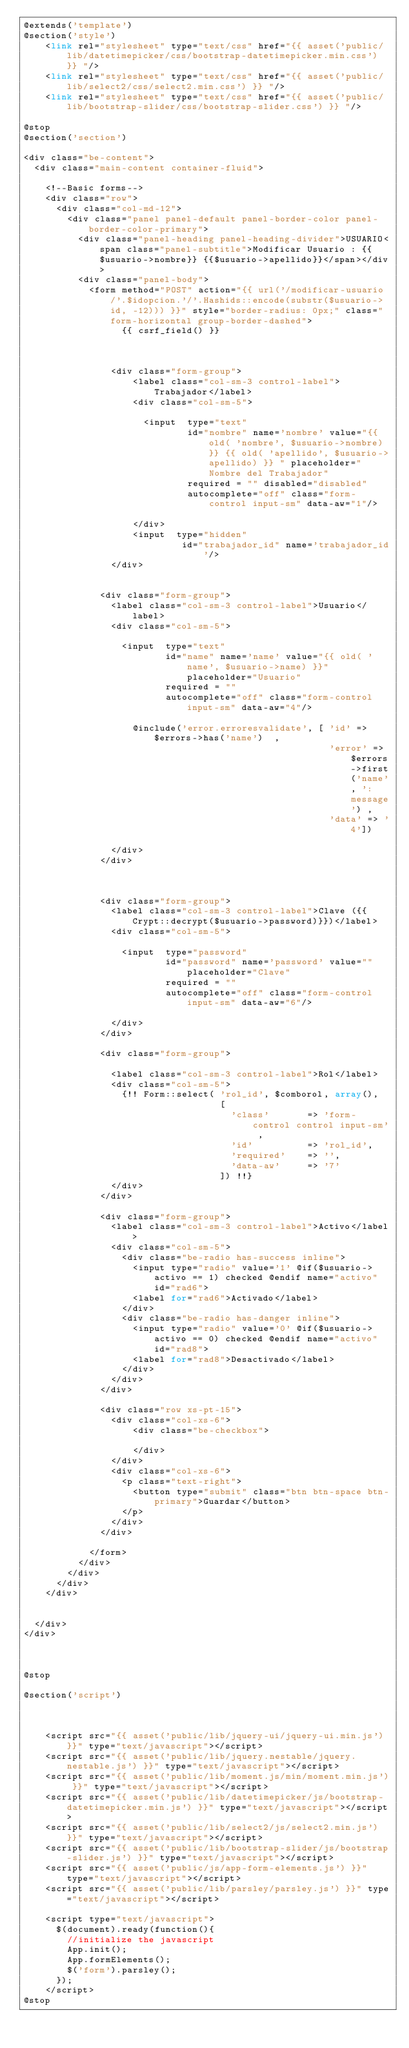Convert code to text. <code><loc_0><loc_0><loc_500><loc_500><_PHP_>@extends('template')
@section('style')
    <link rel="stylesheet" type="text/css" href="{{ asset('public/lib/datetimepicker/css/bootstrap-datetimepicker.min.css') }} "/>
    <link rel="stylesheet" type="text/css" href="{{ asset('public/lib/select2/css/select2.min.css') }} "/>
    <link rel="stylesheet" type="text/css" href="{{ asset('public/lib/bootstrap-slider/css/bootstrap-slider.css') }} "/>

@stop
@section('section')

<div class="be-content">
  <div class="main-content container-fluid">

    <!--Basic forms-->
    <div class="row">
      <div class="col-md-12">
        <div class="panel panel-default panel-border-color panel-border-color-primary">
          <div class="panel-heading panel-heading-divider">USUARIO<span class="panel-subtitle">Modificar Usuario : {{$usuario->nombre}} {{$usuario->apellido}}</span></div>
          <div class="panel-body">
            <form method="POST" action="{{ url('/modificar-usuario/'.$idopcion.'/'.Hashids::encode(substr($usuario->id, -12))) }}" style="border-radius: 0px;" class="form-horizontal group-border-dashed"> 
                  {{ csrf_field() }}


              
                <div class="form-group">
                    <label class="col-sm-3 control-label">Trabajador</label>
                    <div class="col-sm-5">

                      <input  type="text"
                              id="nombre" name='nombre' value="{{ old( 'nombre', $usuario->nombre) }} {{ old( 'apellido', $usuario->apellido) }} " placeholder="Nombre del Trabajador"
                              required = "" disabled="disabled"
                              autocomplete="off" class="form-control input-sm" data-aw="1"/>

                    </div>
                    <input  type="hidden"
                             id="trabajador_id" name='trabajador_id'/>
                </div>
            
            
              <div class="form-group">
                <label class="col-sm-3 control-label">Usuario</label>
                <div class="col-sm-5">

                  <input  type="text"
                          id="name" name='name' value="{{ old( 'name', $usuario->name) }}" placeholder="Usuario"
                          required = ""
                          autocomplete="off" class="form-control input-sm" data-aw="4"/>

                    @include('error.erroresvalidate', [ 'id' => $errors->has('name')  , 
                                                        'error' => $errors->first('name', ':message') , 
                                                        'data' => '4'])

                </div>
              </div>

  

              <div class="form-group">
                <label class="col-sm-3 control-label">Clave ({{Crypt::decrypt($usuario->password)}})</label>
                <div class="col-sm-5">

                  <input  type="password"
                          id="password" name='password' value="" placeholder="Clave"
                          required = ""
                          autocomplete="off" class="form-control input-sm" data-aw="6"/>

                </div>
              </div>

              <div class="form-group">

                <label class="col-sm-3 control-label">Rol</label>
                <div class="col-sm-5">
                  {!! Form::select( 'rol_id', $comborol, array(),
                                    [
                                      'class'       => 'form-control control input-sm' ,
                                      'id'          => 'rol_id',
                                      'required'    => '',
                                      'data-aw'     => '7'
                                    ]) !!}
                </div>
              </div>

              <div class="form-group">
                <label class="col-sm-3 control-label">Activo</label>
                <div class="col-sm-5">
                  <div class="be-radio has-success inline">
                    <input type="radio" value='1' @if($usuario->activo == 1) checked @endif name="activo" id="rad6">
                    <label for="rad6">Activado</label>
                  </div>
                  <div class="be-radio has-danger inline">
                    <input type="radio" value='0' @if($usuario->activo == 0) checked @endif name="activo" id="rad8">
                    <label for="rad8">Desactivado</label>
                  </div>
                </div>
              </div>              

              <div class="row xs-pt-15">
                <div class="col-xs-6">
                    <div class="be-checkbox">

                    </div>
                </div>
                <div class="col-xs-6">
                  <p class="text-right">
                    <button type="submit" class="btn btn-space btn-primary">Guardar</button>
                  </p>
                </div>
              </div>

            </form>
          </div>
        </div>
      </div>
    </div>


  </div>
</div>  



@stop

@section('script')



	  <script src="{{ asset('public/lib/jquery-ui/jquery-ui.min.js') }}" type="text/javascript"></script>
    <script src="{{ asset('public/lib/jquery.nestable/jquery.nestable.js') }}" type="text/javascript"></script>
    <script src="{{ asset('public/lib/moment.js/min/moment.min.js') }}" type="text/javascript"></script>
    <script src="{{ asset('public/lib/datetimepicker/js/bootstrap-datetimepicker.min.js') }}" type="text/javascript"></script>        
    <script src="{{ asset('public/lib/select2/js/select2.min.js') }}" type="text/javascript"></script>
    <script src="{{ asset('public/lib/bootstrap-slider/js/bootstrap-slider.js') }}" type="text/javascript"></script>
    <script src="{{ asset('public/js/app-form-elements.js') }}" type="text/javascript"></script>
    <script src="{{ asset('public/lib/parsley/parsley.js') }}" type="text/javascript"></script>

    <script type="text/javascript">
      $(document).ready(function(){
        //initialize the javascript
        App.init();
        App.formElements();
        $('form').parsley();
      });
    </script> 
@stop</code> 